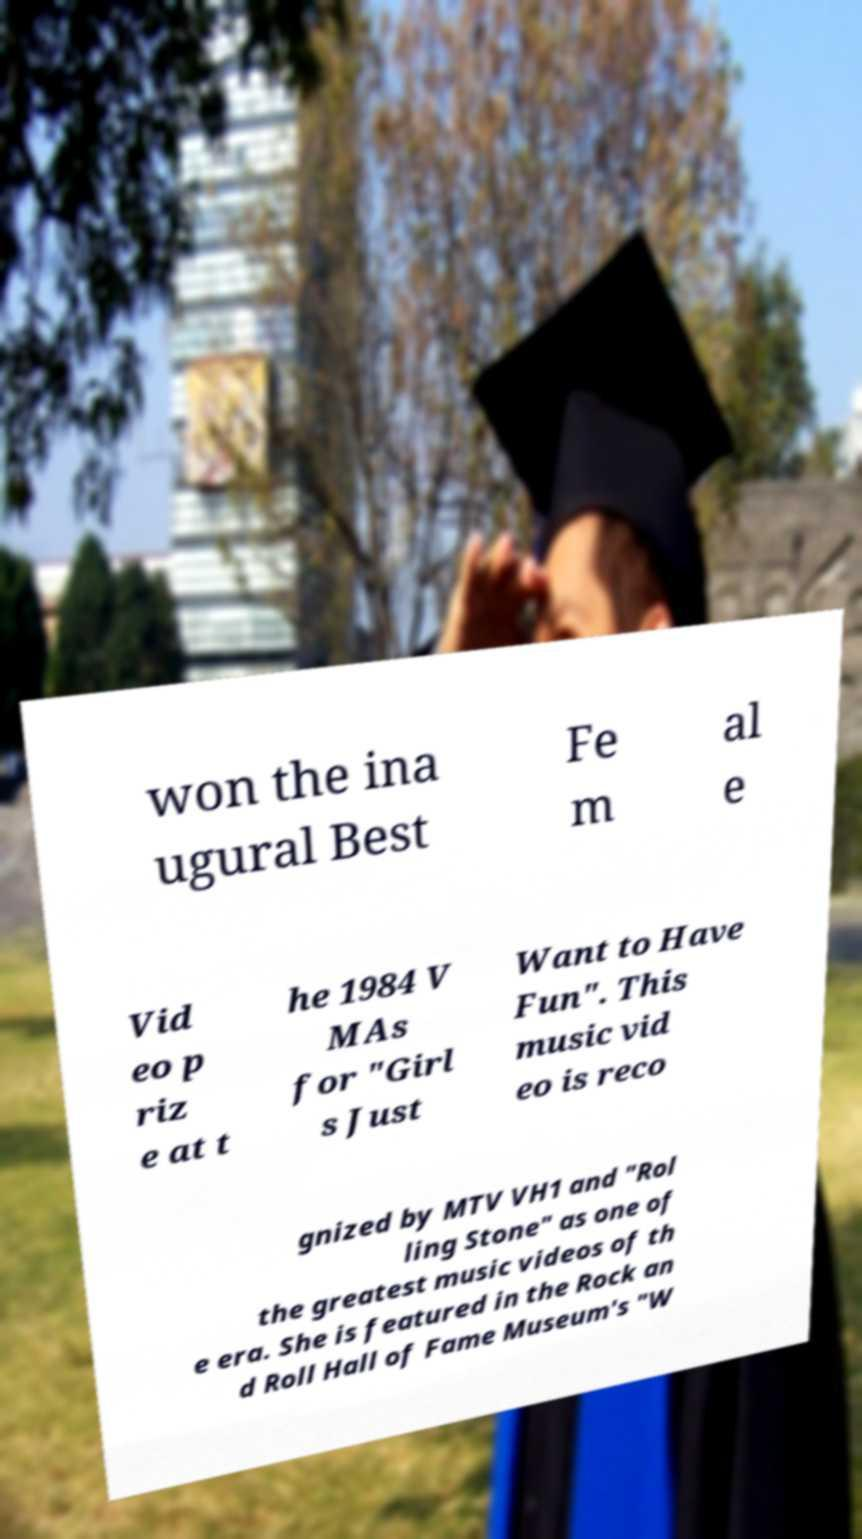There's text embedded in this image that I need extracted. Can you transcribe it verbatim? won the ina ugural Best Fe m al e Vid eo p riz e at t he 1984 V MAs for "Girl s Just Want to Have Fun". This music vid eo is reco gnized by MTV VH1 and "Rol ling Stone" as one of the greatest music videos of th e era. She is featured in the Rock an d Roll Hall of Fame Museum's "W 